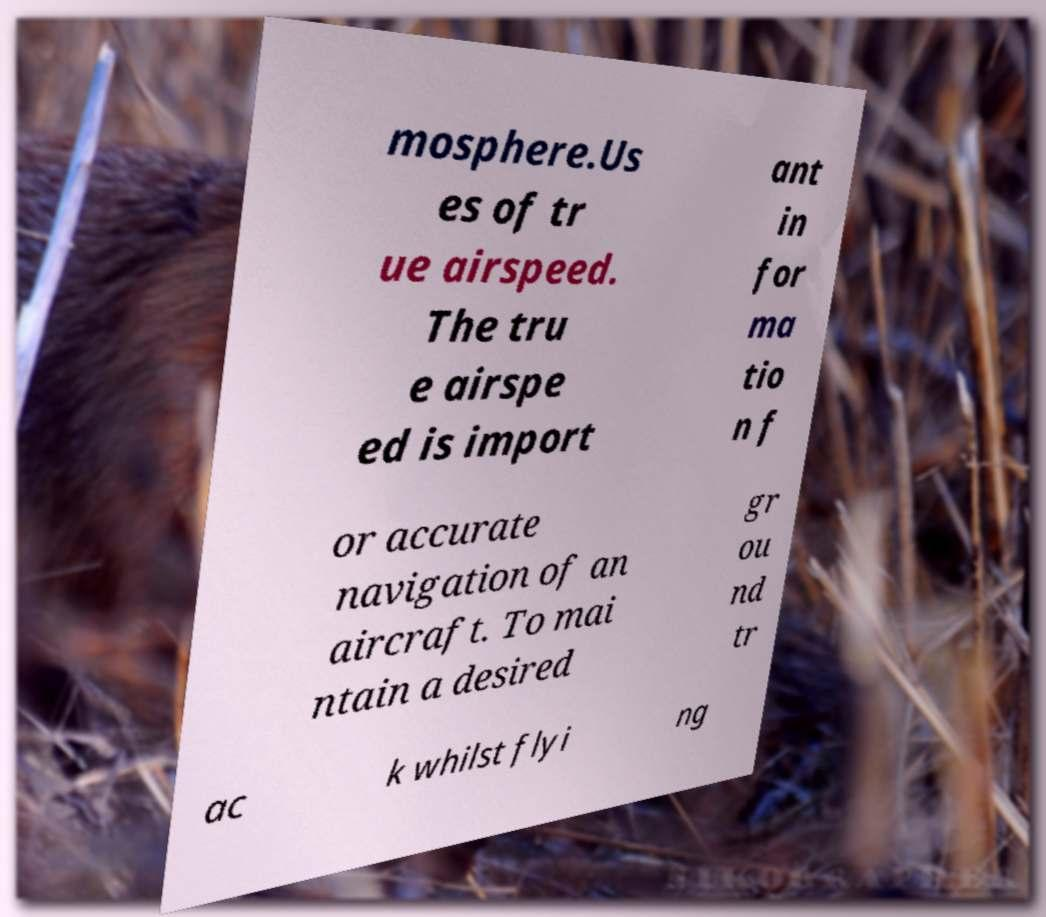There's text embedded in this image that I need extracted. Can you transcribe it verbatim? mosphere.Us es of tr ue airspeed. The tru e airspe ed is import ant in for ma tio n f or accurate navigation of an aircraft. To mai ntain a desired gr ou nd tr ac k whilst flyi ng 